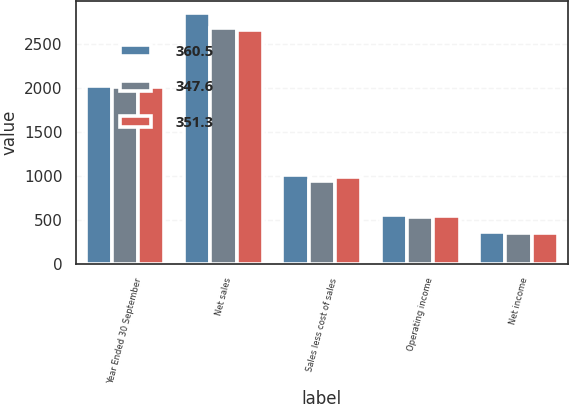<chart> <loc_0><loc_0><loc_500><loc_500><stacked_bar_chart><ecel><fcel>Year Ended 30 September<fcel>Net sales<fcel>Sales less cost of sales<fcel>Operating income<fcel>Net income<nl><fcel>360.5<fcel>2013<fcel>2845.9<fcel>1003.3<fcel>547.3<fcel>360.5<nl><fcel>347.6<fcel>2012<fcel>2675.3<fcel>937<fcel>529.7<fcel>347.6<nl><fcel>351.3<fcel>2011<fcel>2650.5<fcel>987.2<fcel>537<fcel>351.3<nl></chart> 